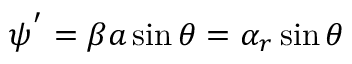Convert formula to latex. <formula><loc_0><loc_0><loc_500><loc_500>\psi ^ { ^ { \prime } } = \beta a \sin \theta = \alpha _ { r } \sin \theta</formula> 